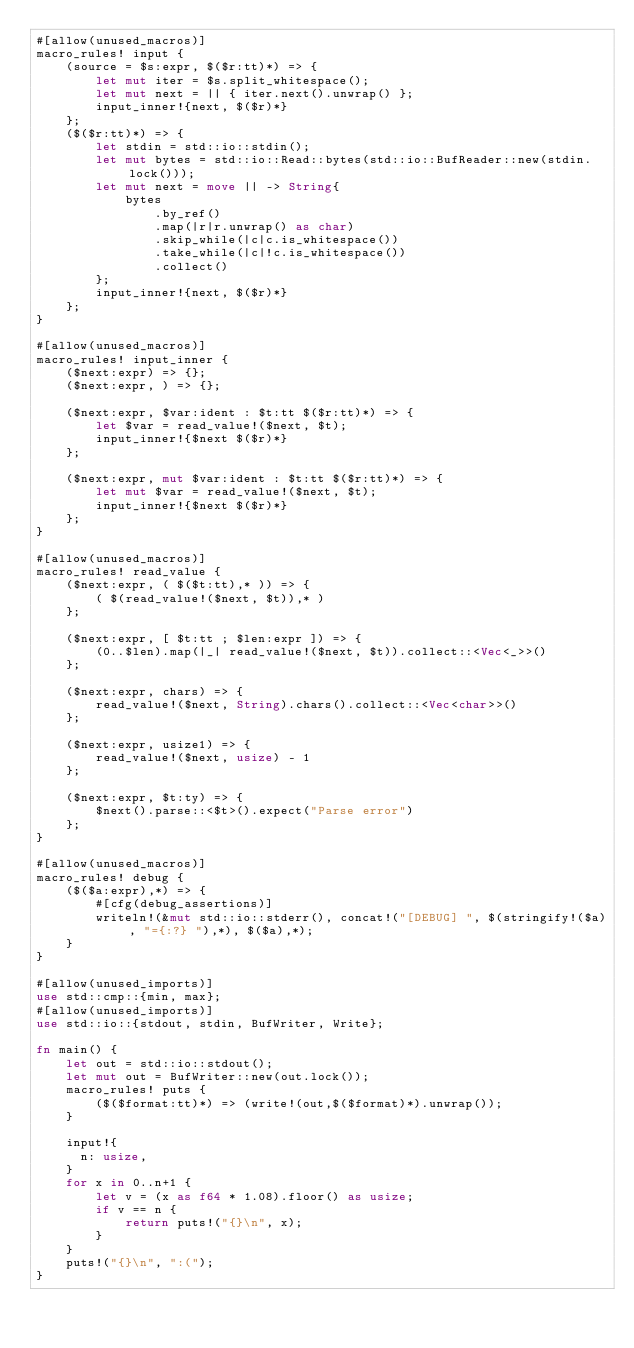Convert code to text. <code><loc_0><loc_0><loc_500><loc_500><_Rust_>#[allow(unused_macros)]
macro_rules! input {
    (source = $s:expr, $($r:tt)*) => {
        let mut iter = $s.split_whitespace();
        let mut next = || { iter.next().unwrap() };
        input_inner!{next, $($r)*}
    };
    ($($r:tt)*) => {
        let stdin = std::io::stdin();
        let mut bytes = std::io::Read::bytes(std::io::BufReader::new(stdin.lock()));
        let mut next = move || -> String{
            bytes
                .by_ref()
                .map(|r|r.unwrap() as char)
                .skip_while(|c|c.is_whitespace())
                .take_while(|c|!c.is_whitespace())
                .collect()
        };
        input_inner!{next, $($r)*}
    };
}

#[allow(unused_macros)]
macro_rules! input_inner {
    ($next:expr) => {};
    ($next:expr, ) => {};

    ($next:expr, $var:ident : $t:tt $($r:tt)*) => {
        let $var = read_value!($next, $t);
        input_inner!{$next $($r)*}
    };

    ($next:expr, mut $var:ident : $t:tt $($r:tt)*) => {
        let mut $var = read_value!($next, $t);
        input_inner!{$next $($r)*}
    };
}

#[allow(unused_macros)]
macro_rules! read_value {
    ($next:expr, ( $($t:tt),* )) => {
        ( $(read_value!($next, $t)),* )
    };

    ($next:expr, [ $t:tt ; $len:expr ]) => {
        (0..$len).map(|_| read_value!($next, $t)).collect::<Vec<_>>()
    };

    ($next:expr, chars) => {
        read_value!($next, String).chars().collect::<Vec<char>>()
    };

    ($next:expr, usize1) => {
        read_value!($next, usize) - 1
    };

    ($next:expr, $t:ty) => {
        $next().parse::<$t>().expect("Parse error")
    };
}

#[allow(unused_macros)]
macro_rules! debug {
    ($($a:expr),*) => {
        #[cfg(debug_assertions)]
        writeln!(&mut std::io::stderr(), concat!("[DEBUG] ", $(stringify!($a), "={:?} "),*), $($a),*);
    }
}

#[allow(unused_imports)]
use std::cmp::{min, max};
#[allow(unused_imports)]
use std::io::{stdout, stdin, BufWriter, Write};

fn main() {
    let out = std::io::stdout();
    let mut out = BufWriter::new(out.lock());
    macro_rules! puts {
        ($($format:tt)*) => (write!(out,$($format)*).unwrap());
    }

    input!{
      n: usize,
    }
    for x in 0..n+1 {
        let v = (x as f64 * 1.08).floor() as usize;
        if v == n {
            return puts!("{}\n", x);
        }
    }
    puts!("{}\n", ":(");
}
</code> 